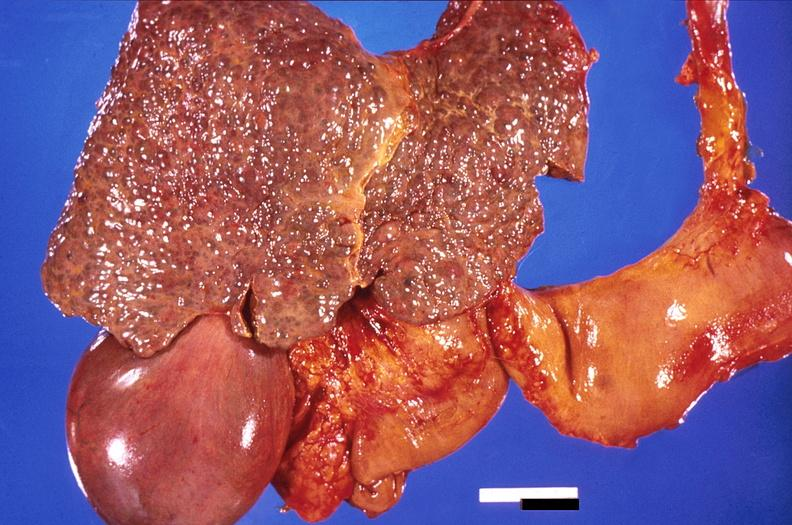s amyloidosis present?
Answer the question using a single word or phrase. No 